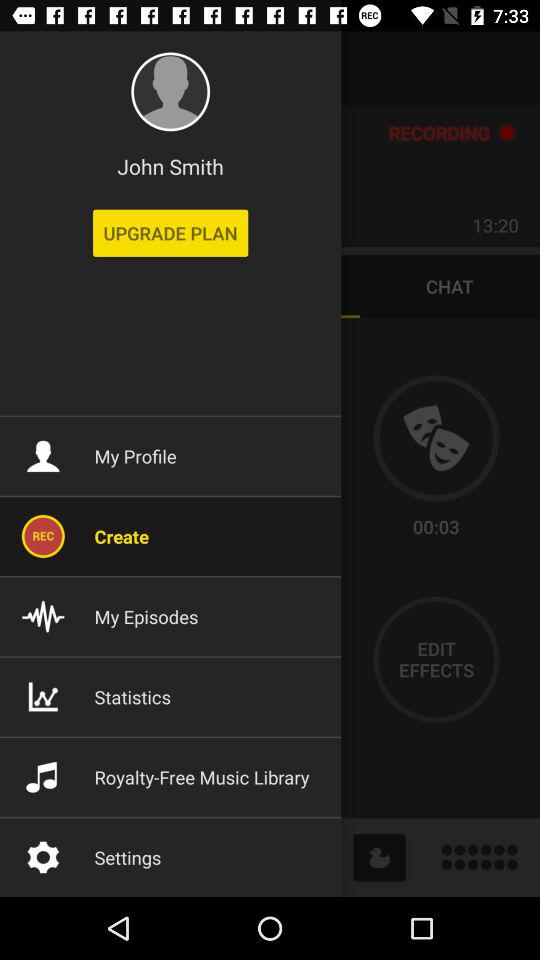What accounts can I use to log in? You can use "FACEBOOK", "TWITTER", "GOOGLE", and "SPREAKER" to log in. 